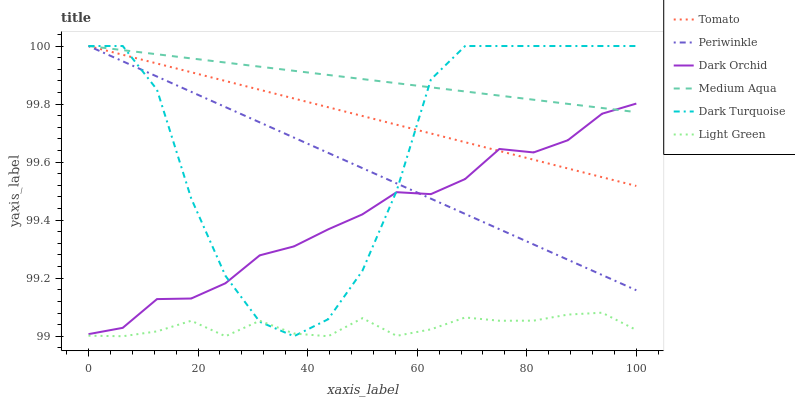Does Light Green have the minimum area under the curve?
Answer yes or no. Yes. Does Medium Aqua have the maximum area under the curve?
Answer yes or no. Yes. Does Dark Turquoise have the minimum area under the curve?
Answer yes or no. No. Does Dark Turquoise have the maximum area under the curve?
Answer yes or no. No. Is Medium Aqua the smoothest?
Answer yes or no. Yes. Is Dark Turquoise the roughest?
Answer yes or no. Yes. Is Dark Orchid the smoothest?
Answer yes or no. No. Is Dark Orchid the roughest?
Answer yes or no. No. Does Light Green have the lowest value?
Answer yes or no. Yes. Does Dark Turquoise have the lowest value?
Answer yes or no. No. Does Periwinkle have the highest value?
Answer yes or no. Yes. Does Dark Orchid have the highest value?
Answer yes or no. No. Is Light Green less than Medium Aqua?
Answer yes or no. Yes. Is Dark Orchid greater than Light Green?
Answer yes or no. Yes. Does Tomato intersect Dark Orchid?
Answer yes or no. Yes. Is Tomato less than Dark Orchid?
Answer yes or no. No. Is Tomato greater than Dark Orchid?
Answer yes or no. No. Does Light Green intersect Medium Aqua?
Answer yes or no. No. 